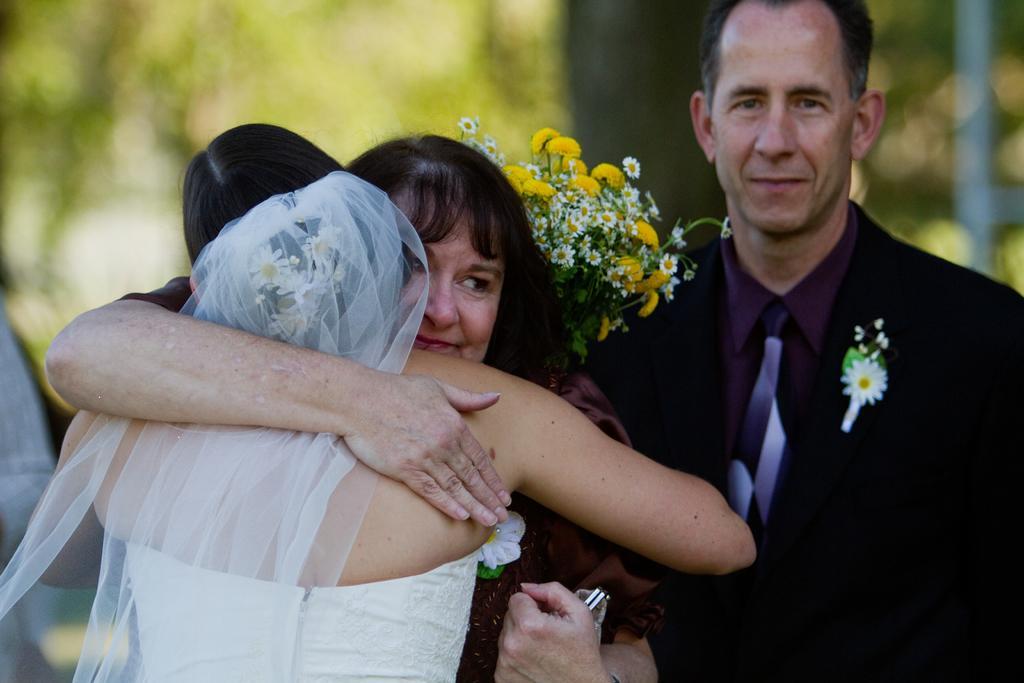In one or two sentences, can you explain what this image depicts? In this image we can see a man wearing white dress is hugging another woman. Here we can see the flower bouquet a person wearing black blazer, tie and shirt is standing here. The background of the image is blurred. 